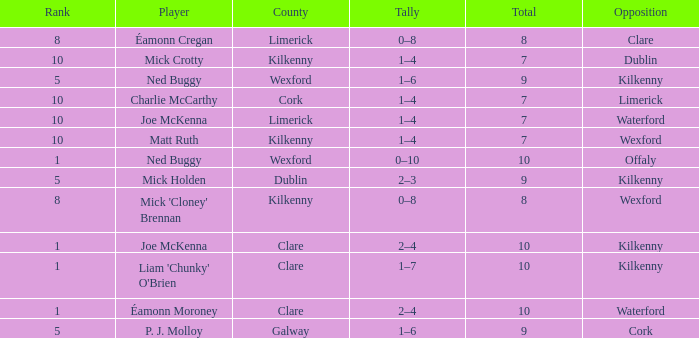What is galway county's total? 9.0. 